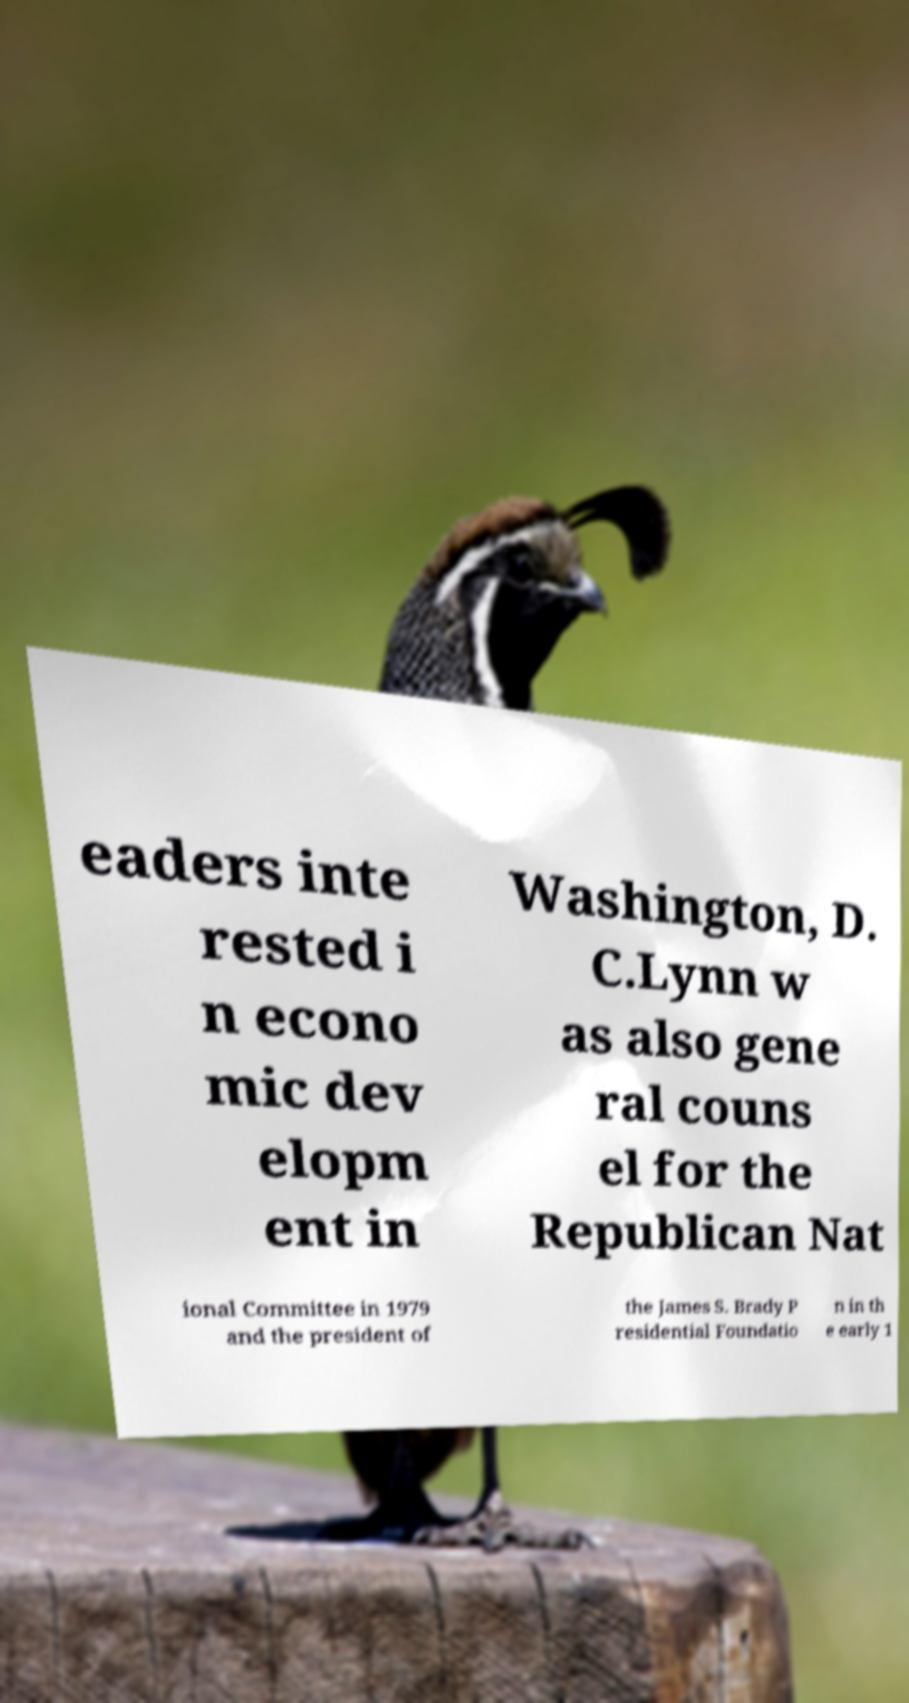Could you extract and type out the text from this image? eaders inte rested i n econo mic dev elopm ent in Washington, D. C.Lynn w as also gene ral couns el for the Republican Nat ional Committee in 1979 and the president of the James S. Brady P residential Foundatio n in th e early 1 